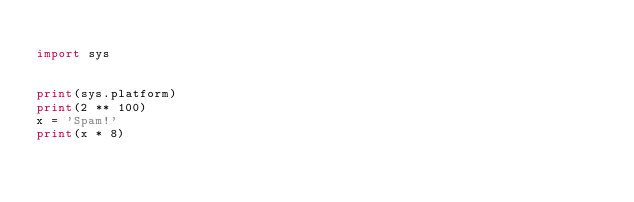Convert code to text. <code><loc_0><loc_0><loc_500><loc_500><_Python_>
import sys


print(sys.platform)
print(2 ** 100)
x = 'Spam!'
print(x * 8)
</code> 